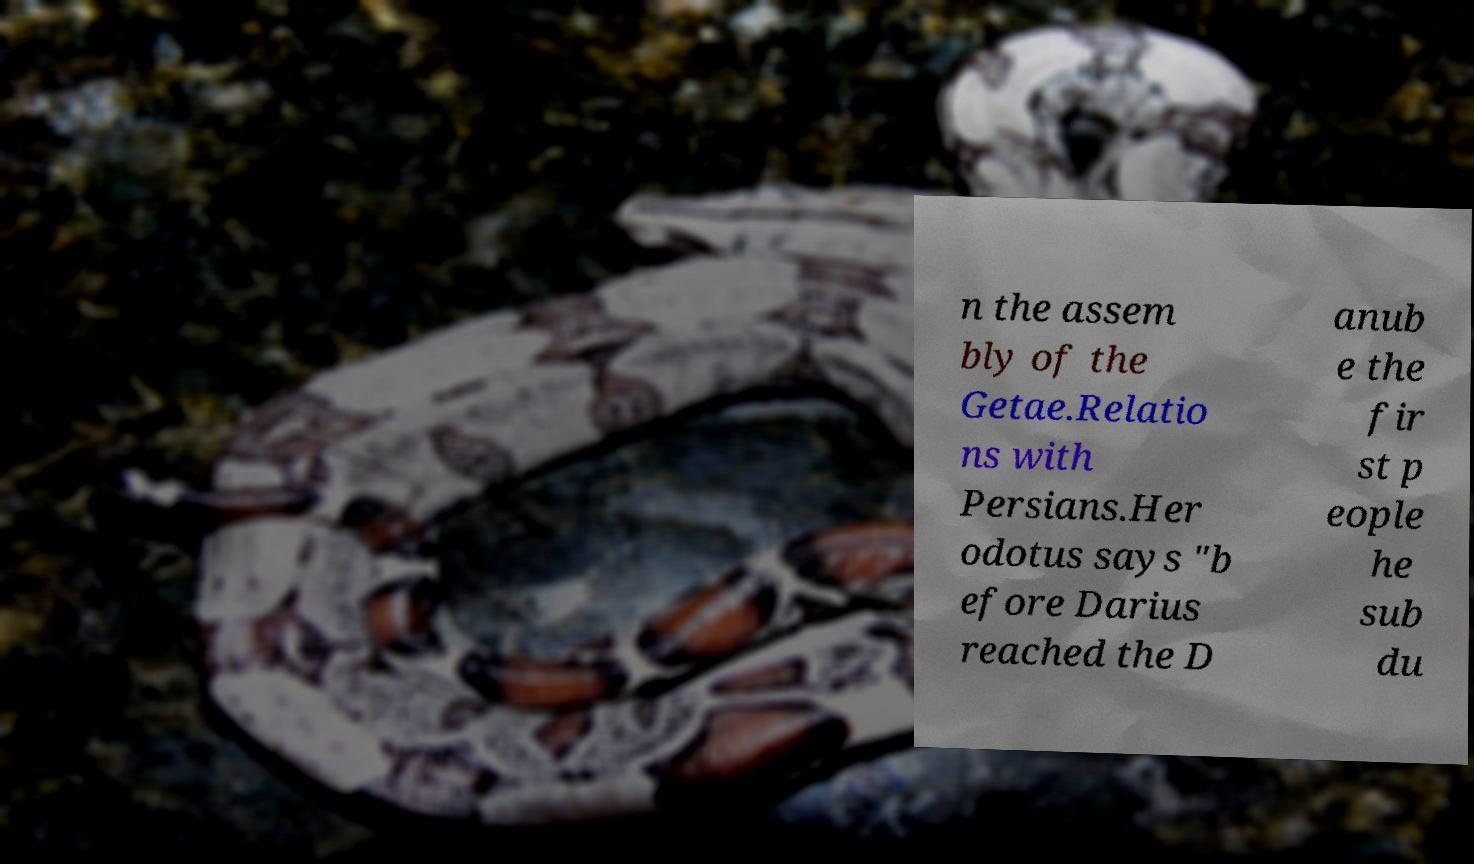Can you accurately transcribe the text from the provided image for me? n the assem bly of the Getae.Relatio ns with Persians.Her odotus says "b efore Darius reached the D anub e the fir st p eople he sub du 